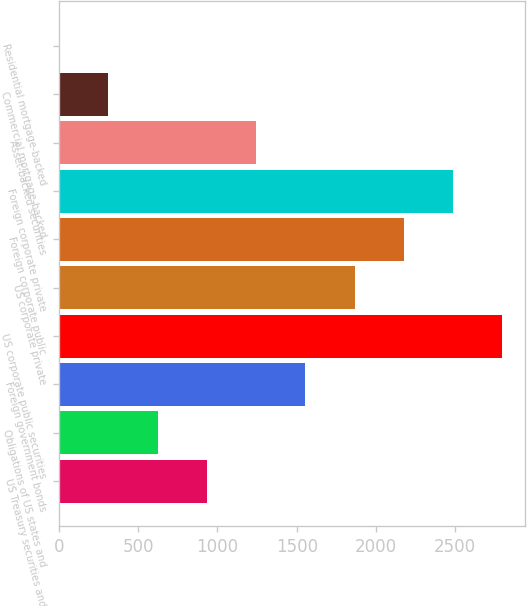Convert chart. <chart><loc_0><loc_0><loc_500><loc_500><bar_chart><fcel>US Treasury securities and<fcel>Obligations of US states and<fcel>Foreign government bonds<fcel>US corporate public securities<fcel>US corporate private<fcel>Foreign corporate public<fcel>Foreign corporate private<fcel>Asset-backed securities<fcel>Commercial mortgage-backed<fcel>Residential mortgage-backed<nl><fcel>933.1<fcel>622.4<fcel>1554.5<fcel>2797.3<fcel>1865.2<fcel>2175.9<fcel>2486.6<fcel>1243.8<fcel>311.7<fcel>1<nl></chart> 